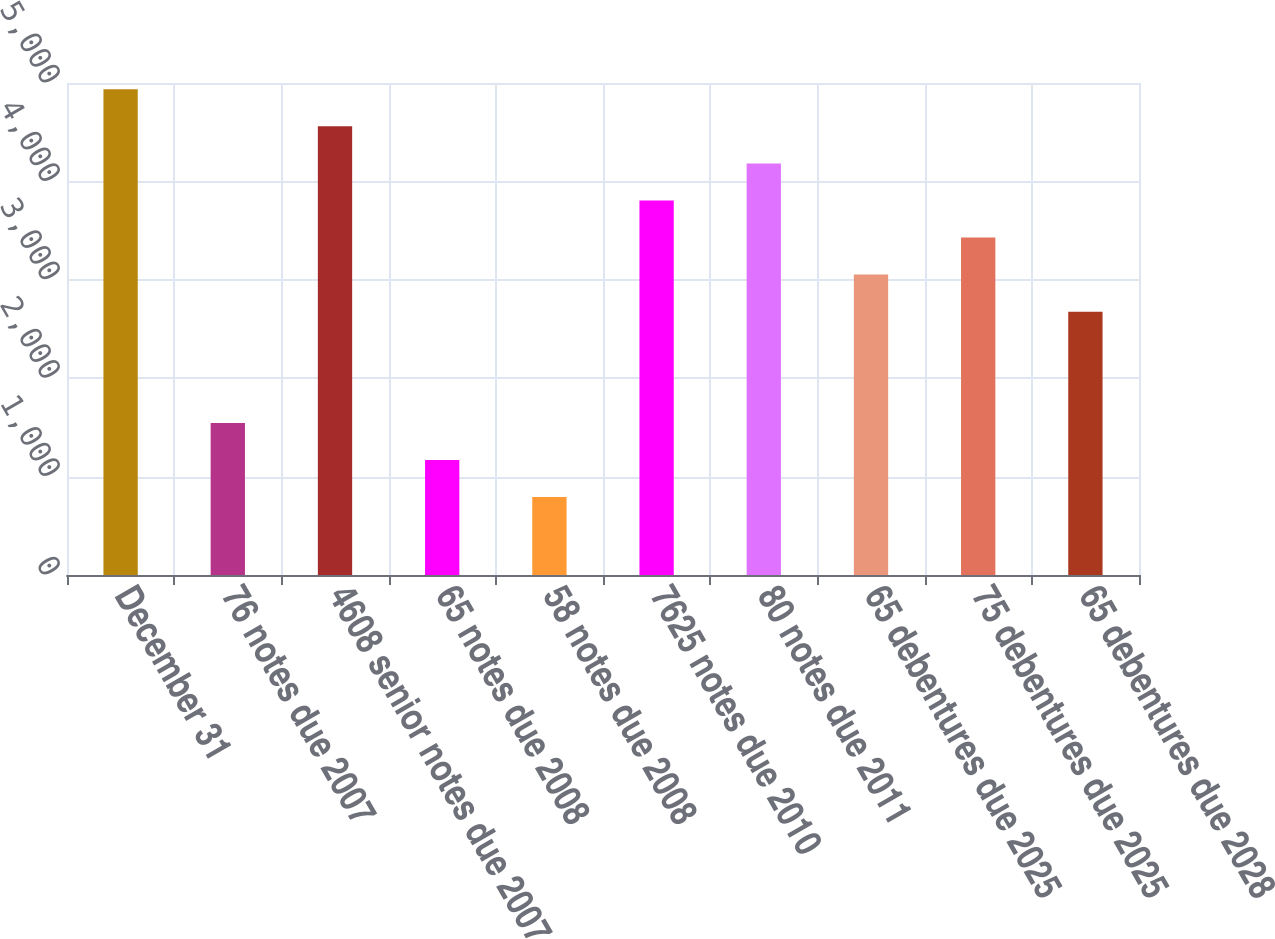<chart> <loc_0><loc_0><loc_500><loc_500><bar_chart><fcel>December 31<fcel>76 notes due 2007<fcel>4608 senior notes due 2007<fcel>65 notes due 2008<fcel>58 notes due 2008<fcel>7625 notes due 2010<fcel>80 notes due 2011<fcel>65 debentures due 2025<fcel>75 debentures due 2025<fcel>65 debentures due 2028<nl><fcel>4936.1<fcel>1545.8<fcel>4559.4<fcel>1169.1<fcel>792.4<fcel>3806<fcel>4182.7<fcel>3052.6<fcel>3429.3<fcel>2675.9<nl></chart> 